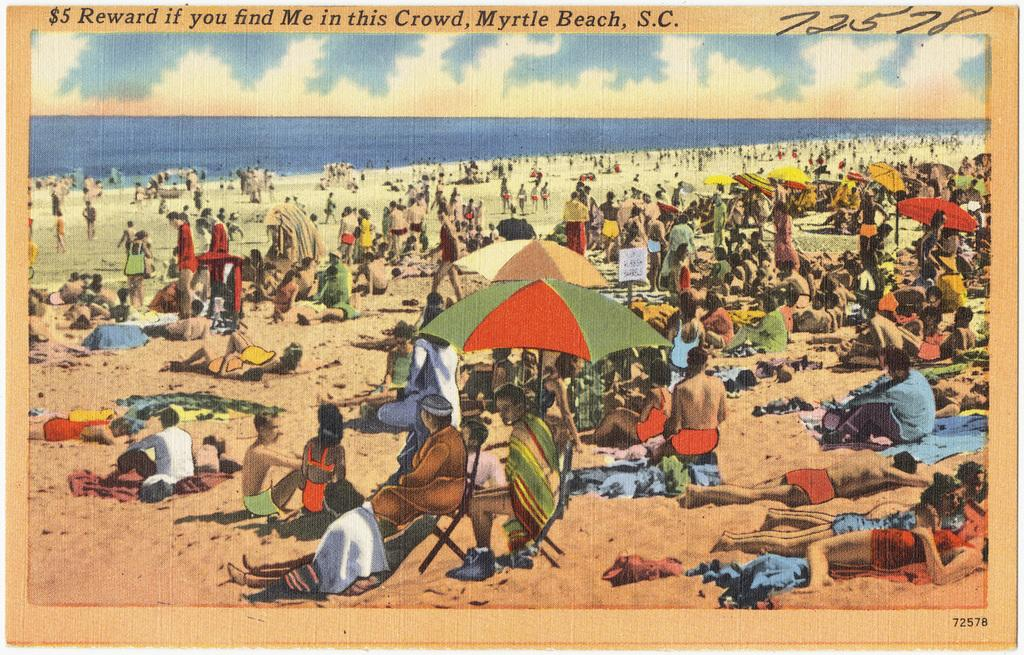<image>
Give a short and clear explanation of the subsequent image. picture of a crowded beach with a $5 reward offered. 